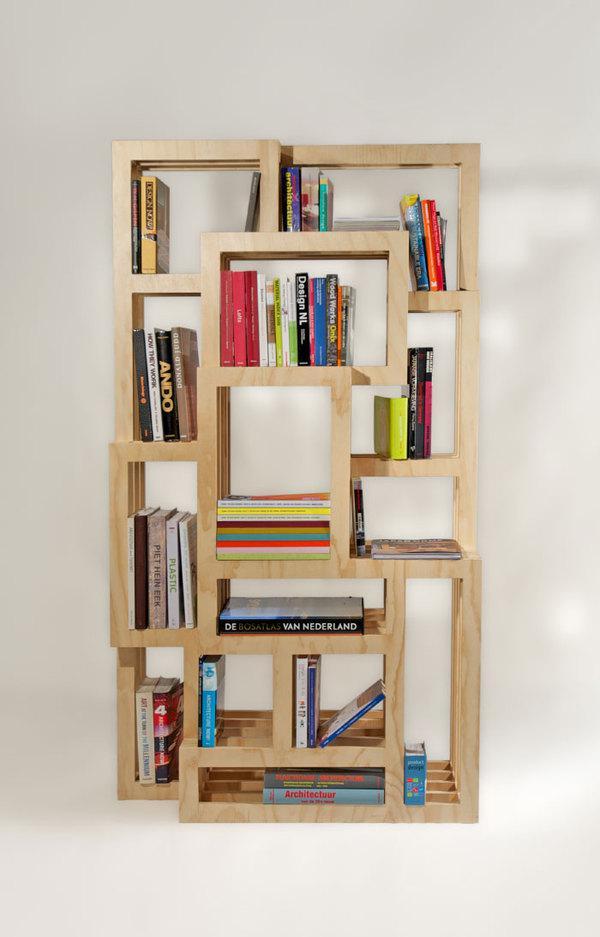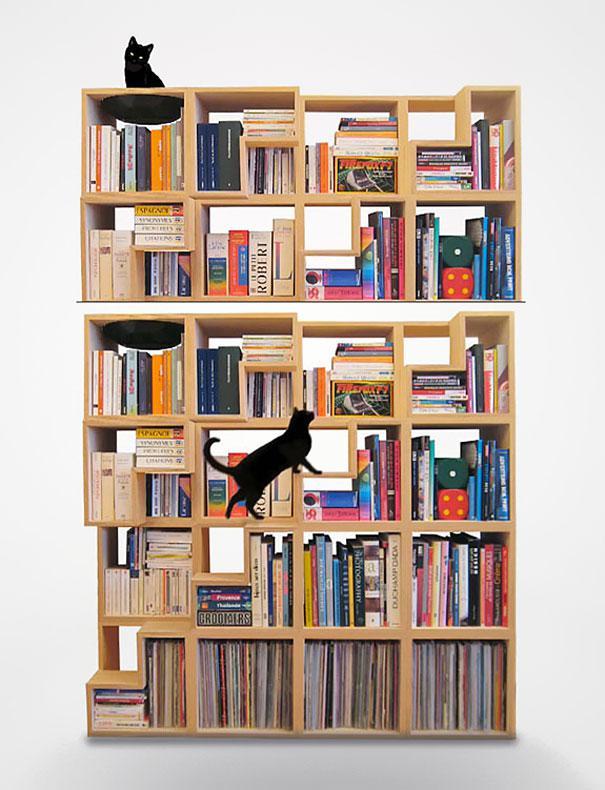The first image is the image on the left, the second image is the image on the right. For the images shown, is this caption "IN at least one image there is a free floating shelving." true? Answer yes or no. No. The first image is the image on the left, the second image is the image on the right. For the images displayed, is the sentence "A shelving unit is attached to the wall." factually correct? Answer yes or no. No. 